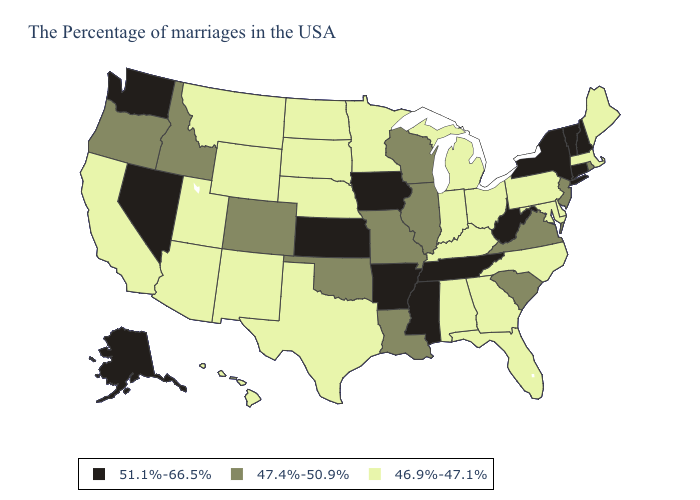What is the lowest value in states that border Mississippi?
Concise answer only. 46.9%-47.1%. Which states have the lowest value in the USA?
Keep it brief. Maine, Massachusetts, Delaware, Maryland, Pennsylvania, North Carolina, Ohio, Florida, Georgia, Michigan, Kentucky, Indiana, Alabama, Minnesota, Nebraska, Texas, South Dakota, North Dakota, Wyoming, New Mexico, Utah, Montana, Arizona, California, Hawaii. What is the highest value in states that border West Virginia?
Give a very brief answer. 47.4%-50.9%. Does New Mexico have the lowest value in the USA?
Quick response, please. Yes. Does Alabama have a higher value than Ohio?
Give a very brief answer. No. Does Delaware have the highest value in the USA?
Quick response, please. No. Name the states that have a value in the range 47.4%-50.9%?
Give a very brief answer. Rhode Island, New Jersey, Virginia, South Carolina, Wisconsin, Illinois, Louisiana, Missouri, Oklahoma, Colorado, Idaho, Oregon. Among the states that border Wisconsin , does Iowa have the highest value?
Keep it brief. Yes. Does Illinois have the lowest value in the MidWest?
Be succinct. No. Which states have the highest value in the USA?
Give a very brief answer. New Hampshire, Vermont, Connecticut, New York, West Virginia, Tennessee, Mississippi, Arkansas, Iowa, Kansas, Nevada, Washington, Alaska. What is the value of Nevada?
Short answer required. 51.1%-66.5%. Which states have the lowest value in the USA?
Give a very brief answer. Maine, Massachusetts, Delaware, Maryland, Pennsylvania, North Carolina, Ohio, Florida, Georgia, Michigan, Kentucky, Indiana, Alabama, Minnesota, Nebraska, Texas, South Dakota, North Dakota, Wyoming, New Mexico, Utah, Montana, Arizona, California, Hawaii. Name the states that have a value in the range 46.9%-47.1%?
Answer briefly. Maine, Massachusetts, Delaware, Maryland, Pennsylvania, North Carolina, Ohio, Florida, Georgia, Michigan, Kentucky, Indiana, Alabama, Minnesota, Nebraska, Texas, South Dakota, North Dakota, Wyoming, New Mexico, Utah, Montana, Arizona, California, Hawaii. Does Massachusetts have a lower value than Oregon?
Be succinct. Yes. 